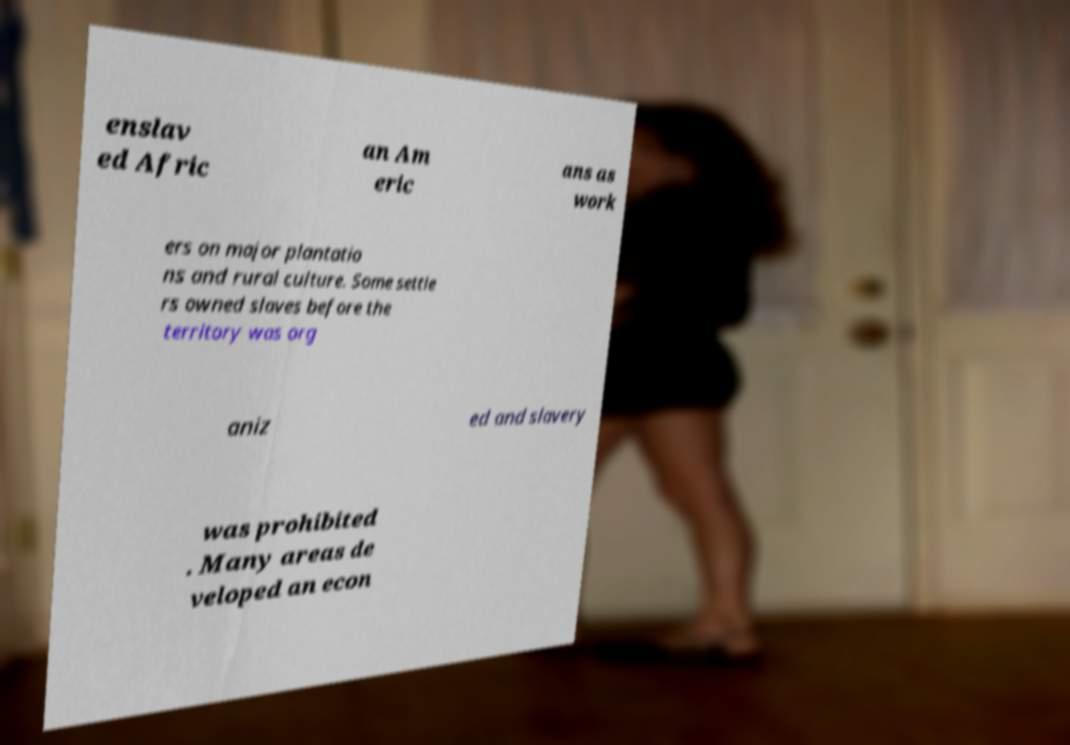There's text embedded in this image that I need extracted. Can you transcribe it verbatim? enslav ed Afric an Am eric ans as work ers on major plantatio ns and rural culture. Some settle rs owned slaves before the territory was org aniz ed and slavery was prohibited . Many areas de veloped an econ 